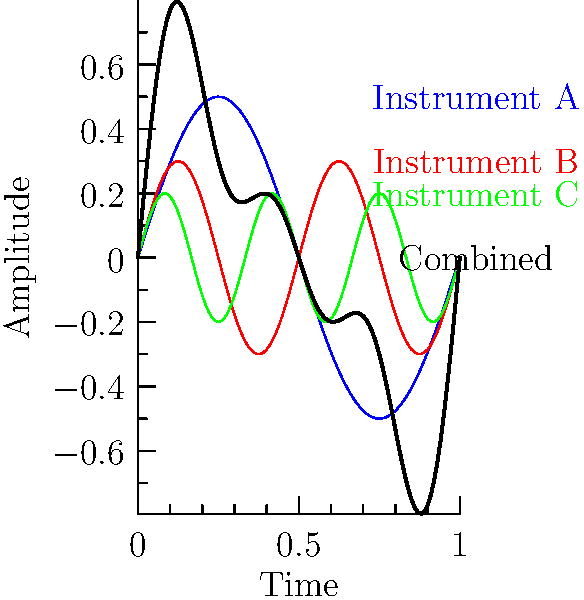As a Grammy-winning musician, you're working on a new track that combines multiple instruments. The waveform above shows the individual and combined audio signals of three different instruments. Which mathematical operation best describes how the black waveform (Combined) is created from the colored waveforms (Instruments A, B, and C)? To answer this question, let's analyze the waveforms step-by-step:

1. We see four waveforms: blue (Instrument A), red (Instrument B), green (Instrument C), and black (Combined).

2. Each colored waveform represents a single instrument's audio signal.

3. The black waveform represents the combined sound of all three instruments.

4. Observing the graph, we can see that at any given point in time:
   - The amplitude of the black wave seems to be the sum of the amplitudes of the three colored waves.

5. In audio signal processing, when multiple sound waves are combined, their amplitudes add together. This process is called superposition.

6. Mathematically, if we denote the waveforms as functions:
   $f_A(t)$ for Instrument A
   $f_B(t)$ for Instrument B
   $f_C(t)$ for Instrument C
   $f_{combined}(t)$ for the Combined waveform

   Then, $f_{combined}(t) = f_A(t) + f_B(t) + f_C(t)$

7. This operation of adding the individual waveforms to create the combined waveform is best described as addition or summation.
Answer: Addition 